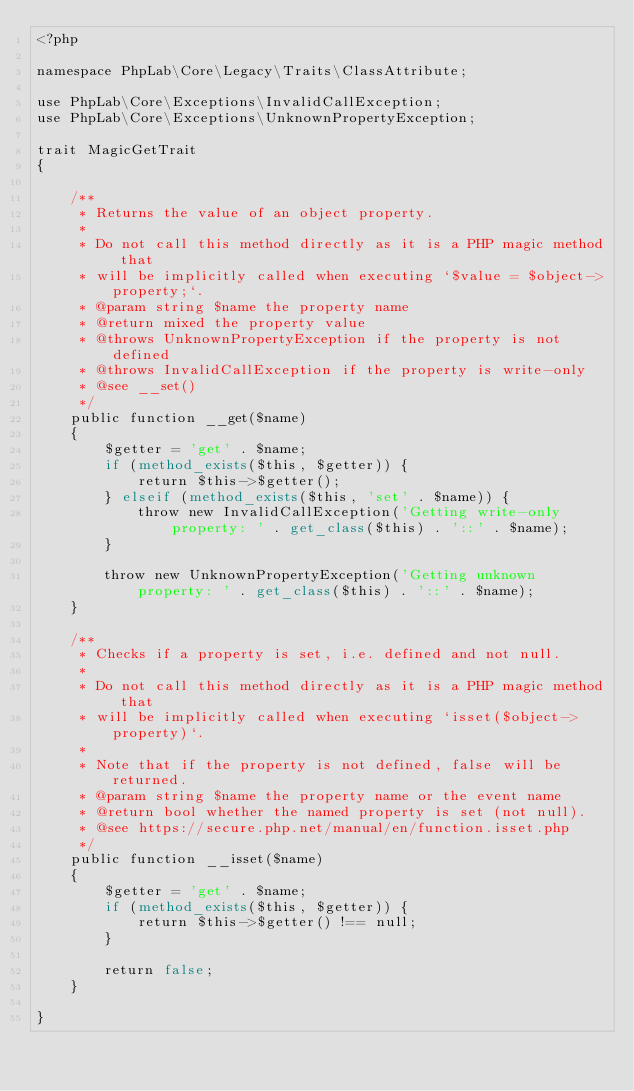<code> <loc_0><loc_0><loc_500><loc_500><_PHP_><?php

namespace PhpLab\Core\Legacy\Traits\ClassAttribute;

use PhpLab\Core\Exceptions\InvalidCallException;
use PhpLab\Core\Exceptions\UnknownPropertyException;

trait MagicGetTrait
{

    /**
     * Returns the value of an object property.
     *
     * Do not call this method directly as it is a PHP magic method that
     * will be implicitly called when executing `$value = $object->property;`.
     * @param string $name the property name
     * @return mixed the property value
     * @throws UnknownPropertyException if the property is not defined
     * @throws InvalidCallException if the property is write-only
     * @see __set()
     */
    public function __get($name)
    {
        $getter = 'get' . $name;
        if (method_exists($this, $getter)) {
            return $this->$getter();
        } elseif (method_exists($this, 'set' . $name)) {
            throw new InvalidCallException('Getting write-only property: ' . get_class($this) . '::' . $name);
        }

        throw new UnknownPropertyException('Getting unknown property: ' . get_class($this) . '::' . $name);
    }

    /**
     * Checks if a property is set, i.e. defined and not null.
     *
     * Do not call this method directly as it is a PHP magic method that
     * will be implicitly called when executing `isset($object->property)`.
     *
     * Note that if the property is not defined, false will be returned.
     * @param string $name the property name or the event name
     * @return bool whether the named property is set (not null).
     * @see https://secure.php.net/manual/en/function.isset.php
     */
    public function __isset($name)
    {
        $getter = 'get' . $name;
        if (method_exists($this, $getter)) {
            return $this->$getter() !== null;
        }

        return false;
    }

}
</code> 